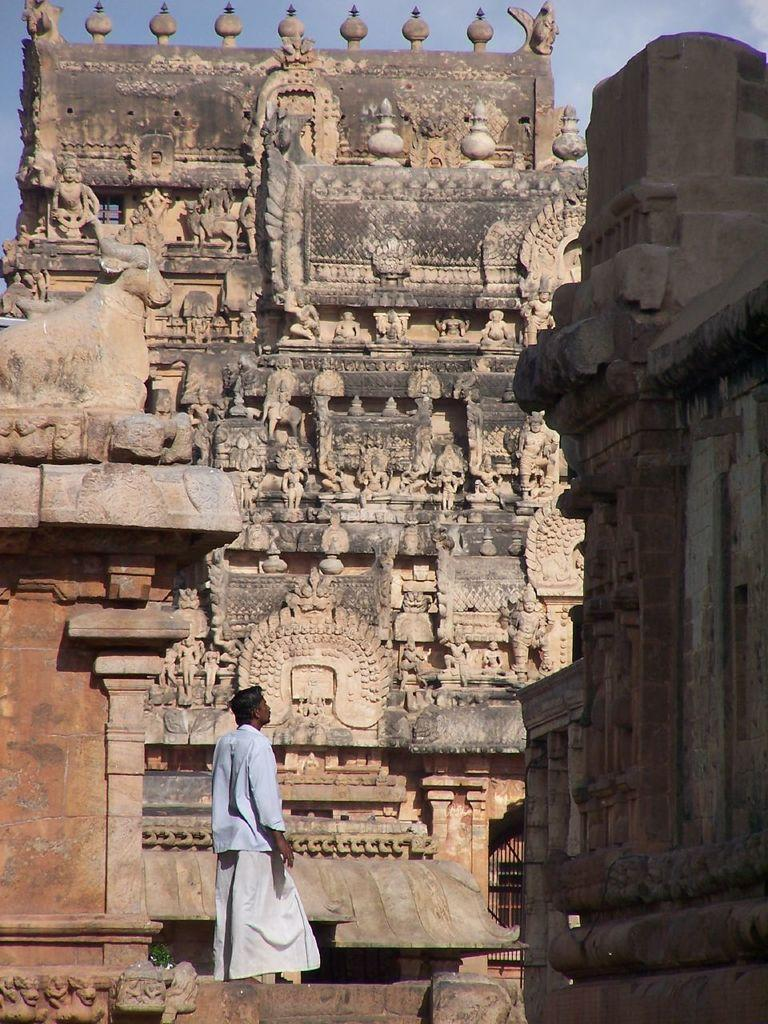What type of structures can be seen in the image? There are buildings in the image. Can you describe a specific building in the image? There is a building with sculptures in the image. What is happening in front of the building with sculptures? A man is standing in front of the building with sculptures. What can be seen in the background of the image? The sky is visible in the background of the image. What type of drink is the frog holding in the image? There is no frog present in the image, and therefore no drink can be observed. 